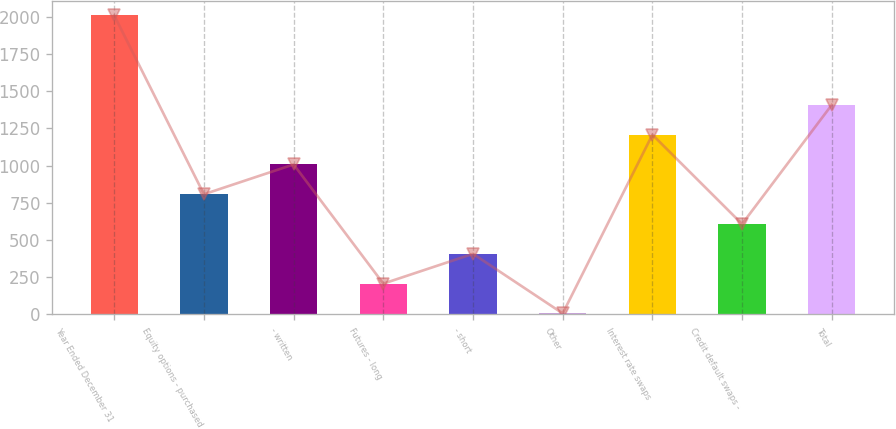Convert chart. <chart><loc_0><loc_0><loc_500><loc_500><bar_chart><fcel>Year Ended December 31<fcel>Equity options - purchased<fcel>- written<fcel>Futures - long<fcel>- short<fcel>Other<fcel>Interest rate swaps<fcel>Credit default swaps -<fcel>Total<nl><fcel>2009<fcel>807.8<fcel>1008<fcel>207.2<fcel>407.4<fcel>7<fcel>1208.2<fcel>607.6<fcel>1408.4<nl></chart> 